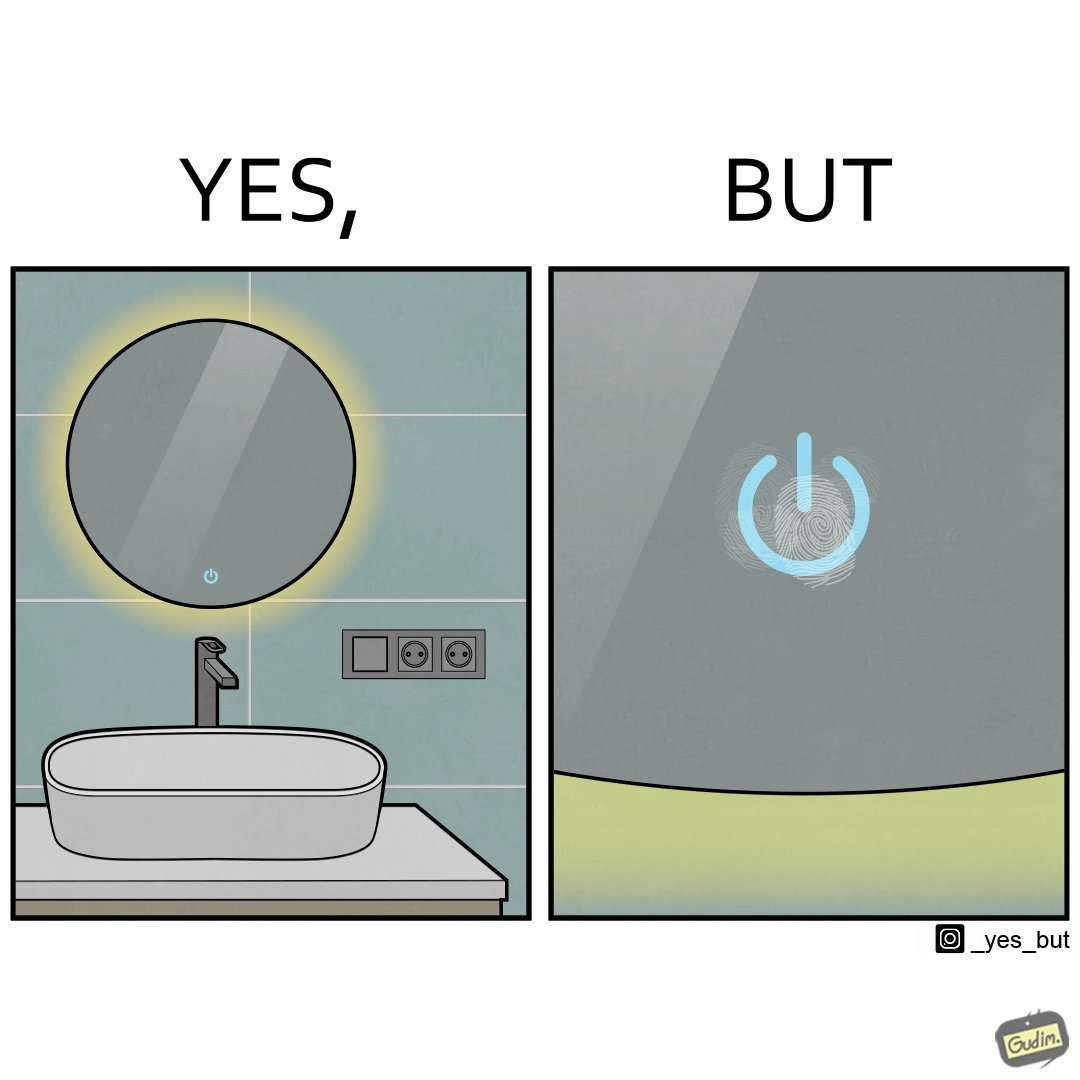What does this image depict? The image is funny, as the bathroom sink looks clean, but when you zoom into the touch power button, you can see fingerprint smudges. 